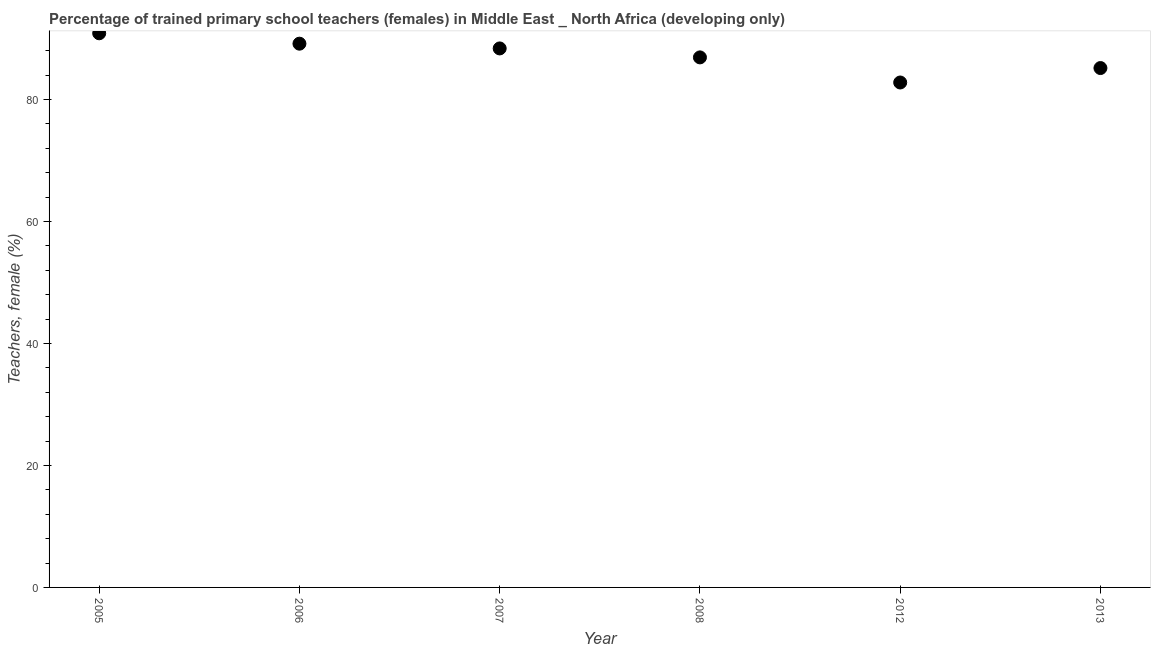What is the percentage of trained female teachers in 2006?
Your answer should be compact. 89.15. Across all years, what is the maximum percentage of trained female teachers?
Give a very brief answer. 90.85. Across all years, what is the minimum percentage of trained female teachers?
Your answer should be very brief. 82.79. In which year was the percentage of trained female teachers maximum?
Ensure brevity in your answer.  2005. What is the sum of the percentage of trained female teachers?
Keep it short and to the point. 523.22. What is the difference between the percentage of trained female teachers in 2012 and 2013?
Provide a short and direct response. -2.37. What is the average percentage of trained female teachers per year?
Your answer should be compact. 87.2. What is the median percentage of trained female teachers?
Provide a succinct answer. 87.64. What is the ratio of the percentage of trained female teachers in 2006 to that in 2008?
Provide a succinct answer. 1.03. Is the difference between the percentage of trained female teachers in 2007 and 2012 greater than the difference between any two years?
Make the answer very short. No. What is the difference between the highest and the second highest percentage of trained female teachers?
Your response must be concise. 1.7. Is the sum of the percentage of trained female teachers in 2006 and 2007 greater than the maximum percentage of trained female teachers across all years?
Provide a short and direct response. Yes. What is the difference between the highest and the lowest percentage of trained female teachers?
Offer a terse response. 8.07. What is the difference between two consecutive major ticks on the Y-axis?
Offer a terse response. 20. Does the graph contain grids?
Make the answer very short. No. What is the title of the graph?
Your response must be concise. Percentage of trained primary school teachers (females) in Middle East _ North Africa (developing only). What is the label or title of the X-axis?
Ensure brevity in your answer.  Year. What is the label or title of the Y-axis?
Keep it short and to the point. Teachers, female (%). What is the Teachers, female (%) in 2005?
Keep it short and to the point. 90.85. What is the Teachers, female (%) in 2006?
Your answer should be very brief. 89.15. What is the Teachers, female (%) in 2007?
Provide a short and direct response. 88.37. What is the Teachers, female (%) in 2008?
Your answer should be compact. 86.9. What is the Teachers, female (%) in 2012?
Keep it short and to the point. 82.79. What is the Teachers, female (%) in 2013?
Keep it short and to the point. 85.15. What is the difference between the Teachers, female (%) in 2005 and 2006?
Your answer should be compact. 1.7. What is the difference between the Teachers, female (%) in 2005 and 2007?
Give a very brief answer. 2.48. What is the difference between the Teachers, female (%) in 2005 and 2008?
Provide a short and direct response. 3.95. What is the difference between the Teachers, female (%) in 2005 and 2012?
Your answer should be compact. 8.07. What is the difference between the Teachers, female (%) in 2005 and 2013?
Keep it short and to the point. 5.7. What is the difference between the Teachers, female (%) in 2006 and 2007?
Provide a succinct answer. 0.78. What is the difference between the Teachers, female (%) in 2006 and 2008?
Your answer should be very brief. 2.25. What is the difference between the Teachers, female (%) in 2006 and 2012?
Your answer should be very brief. 6.36. What is the difference between the Teachers, female (%) in 2006 and 2013?
Offer a very short reply. 4. What is the difference between the Teachers, female (%) in 2007 and 2008?
Provide a succinct answer. 1.47. What is the difference between the Teachers, female (%) in 2007 and 2012?
Your answer should be compact. 5.59. What is the difference between the Teachers, female (%) in 2007 and 2013?
Give a very brief answer. 3.22. What is the difference between the Teachers, female (%) in 2008 and 2012?
Offer a terse response. 4.12. What is the difference between the Teachers, female (%) in 2008 and 2013?
Keep it short and to the point. 1.75. What is the difference between the Teachers, female (%) in 2012 and 2013?
Provide a succinct answer. -2.37. What is the ratio of the Teachers, female (%) in 2005 to that in 2006?
Offer a very short reply. 1.02. What is the ratio of the Teachers, female (%) in 2005 to that in 2007?
Your answer should be compact. 1.03. What is the ratio of the Teachers, female (%) in 2005 to that in 2008?
Provide a short and direct response. 1.04. What is the ratio of the Teachers, female (%) in 2005 to that in 2012?
Ensure brevity in your answer.  1.1. What is the ratio of the Teachers, female (%) in 2005 to that in 2013?
Provide a succinct answer. 1.07. What is the ratio of the Teachers, female (%) in 2006 to that in 2012?
Give a very brief answer. 1.08. What is the ratio of the Teachers, female (%) in 2006 to that in 2013?
Your answer should be compact. 1.05. What is the ratio of the Teachers, female (%) in 2007 to that in 2012?
Offer a very short reply. 1.07. What is the ratio of the Teachers, female (%) in 2007 to that in 2013?
Keep it short and to the point. 1.04. What is the ratio of the Teachers, female (%) in 2012 to that in 2013?
Make the answer very short. 0.97. 